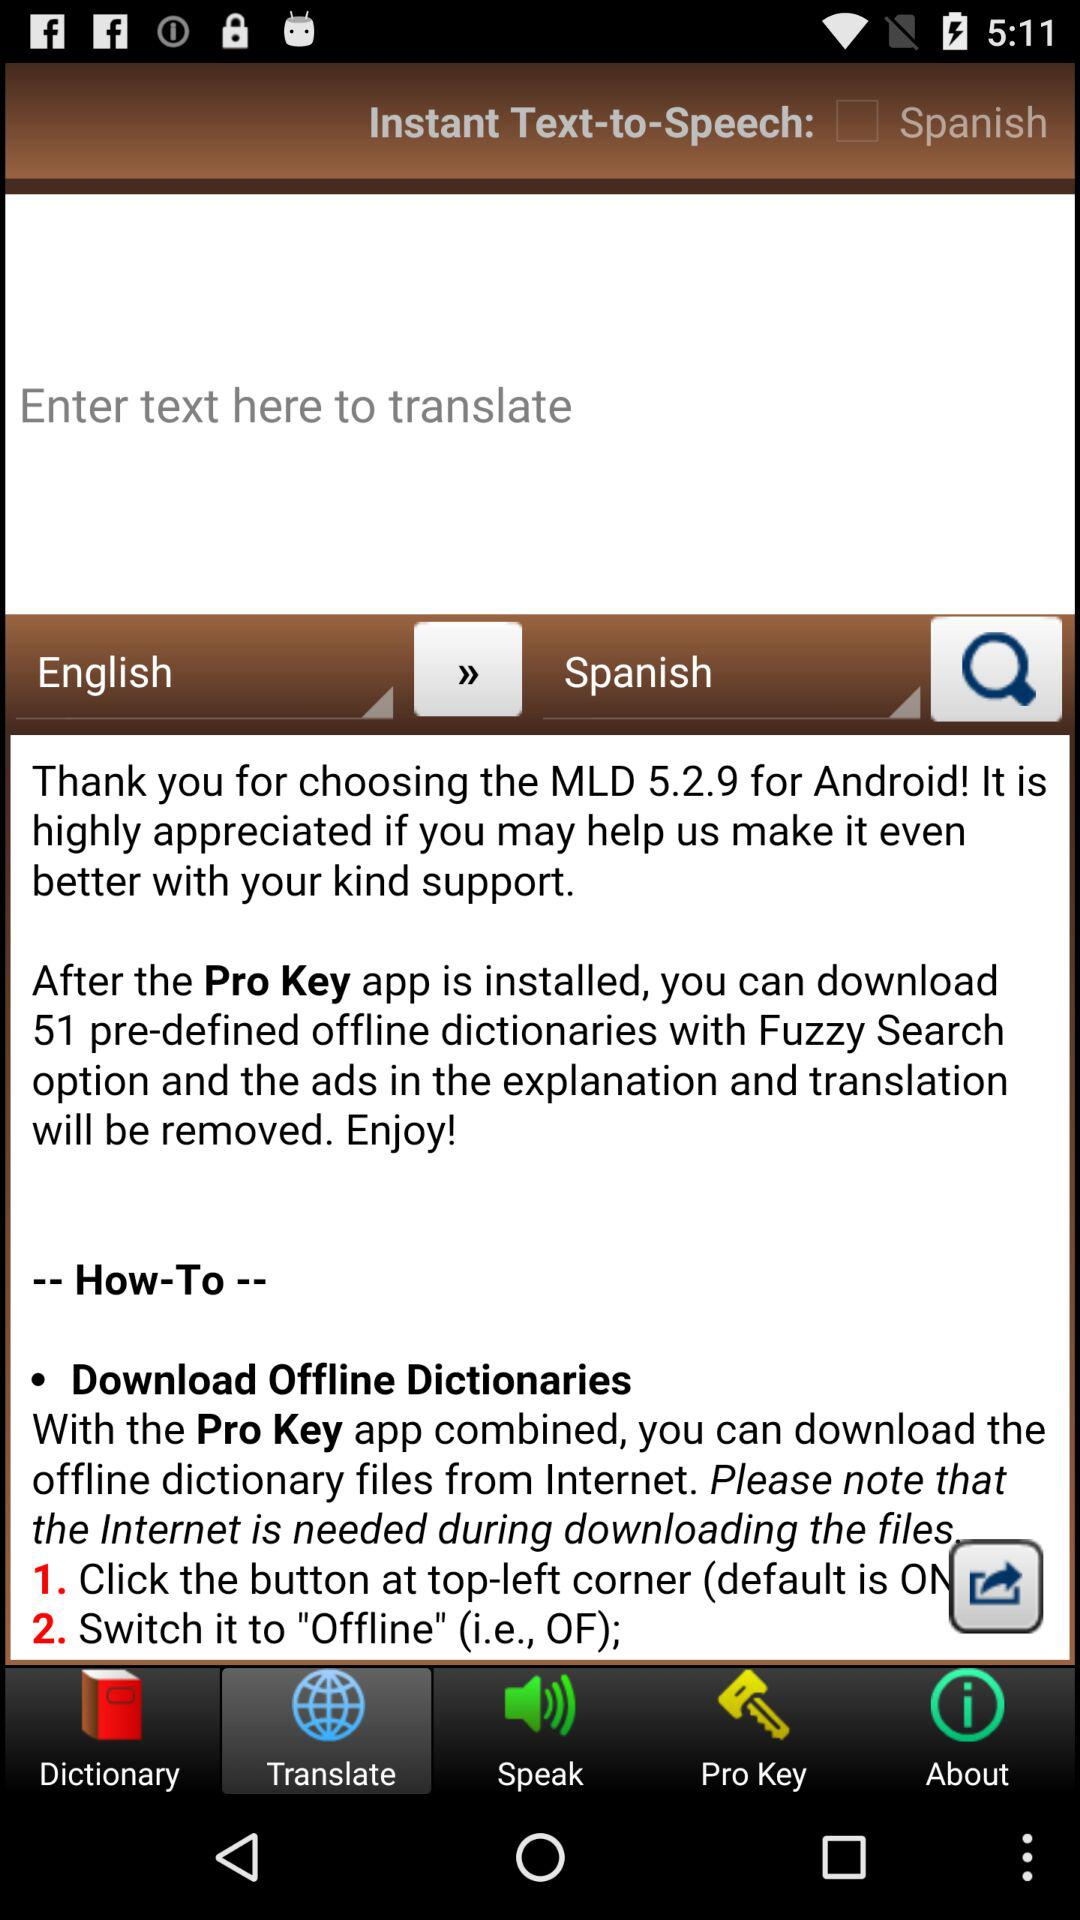How many offline dictionaries can be downloaded?
Answer the question using a single word or phrase. 51 